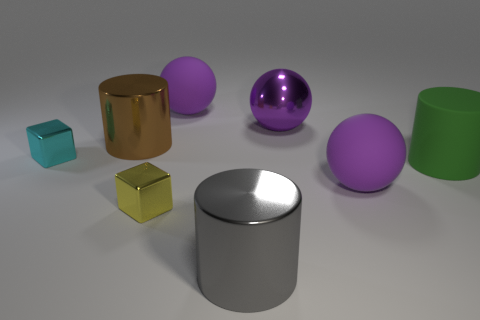How many purple balls must be subtracted to get 1 purple balls? 2 Subtract all metal cylinders. How many cylinders are left? 1 Add 2 spheres. How many objects exist? 10 Subtract all brown spheres. Subtract all blue cylinders. How many spheres are left? 3 Add 3 purple matte balls. How many purple matte balls exist? 5 Subtract 1 gray cylinders. How many objects are left? 7 Subtract all cylinders. How many objects are left? 5 Subtract all large green metal objects. Subtract all brown metallic things. How many objects are left? 7 Add 4 purple things. How many purple things are left? 7 